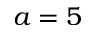<formula> <loc_0><loc_0><loc_500><loc_500>a = 5</formula> 